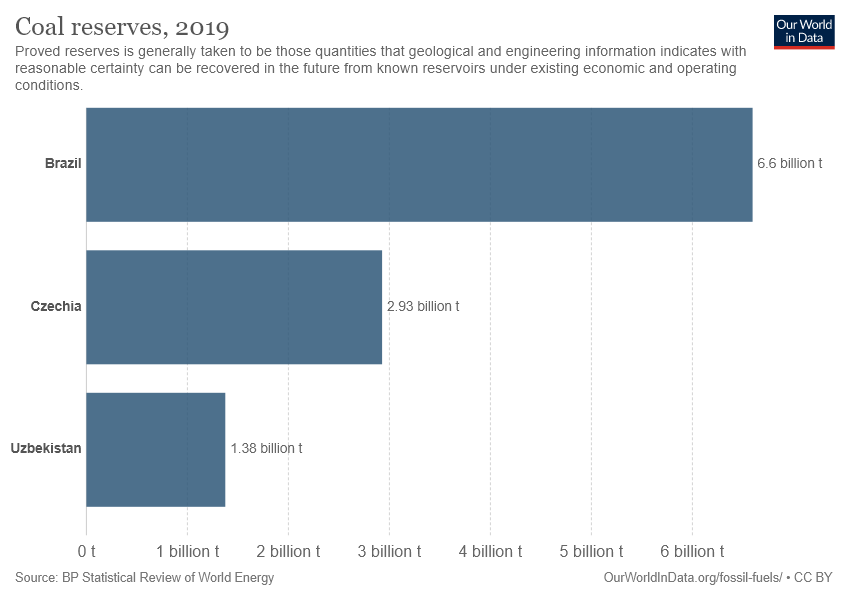Identify some key points in this picture. The total coal reserves of Czechia and Uzbekistan do not exceed those of Brazil. In 2019, Brazil was determined to have the largest reserves of coal. 